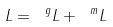<formula> <loc_0><loc_0><loc_500><loc_500>L = \ ^ { g } L + \ ^ { m } L</formula> 